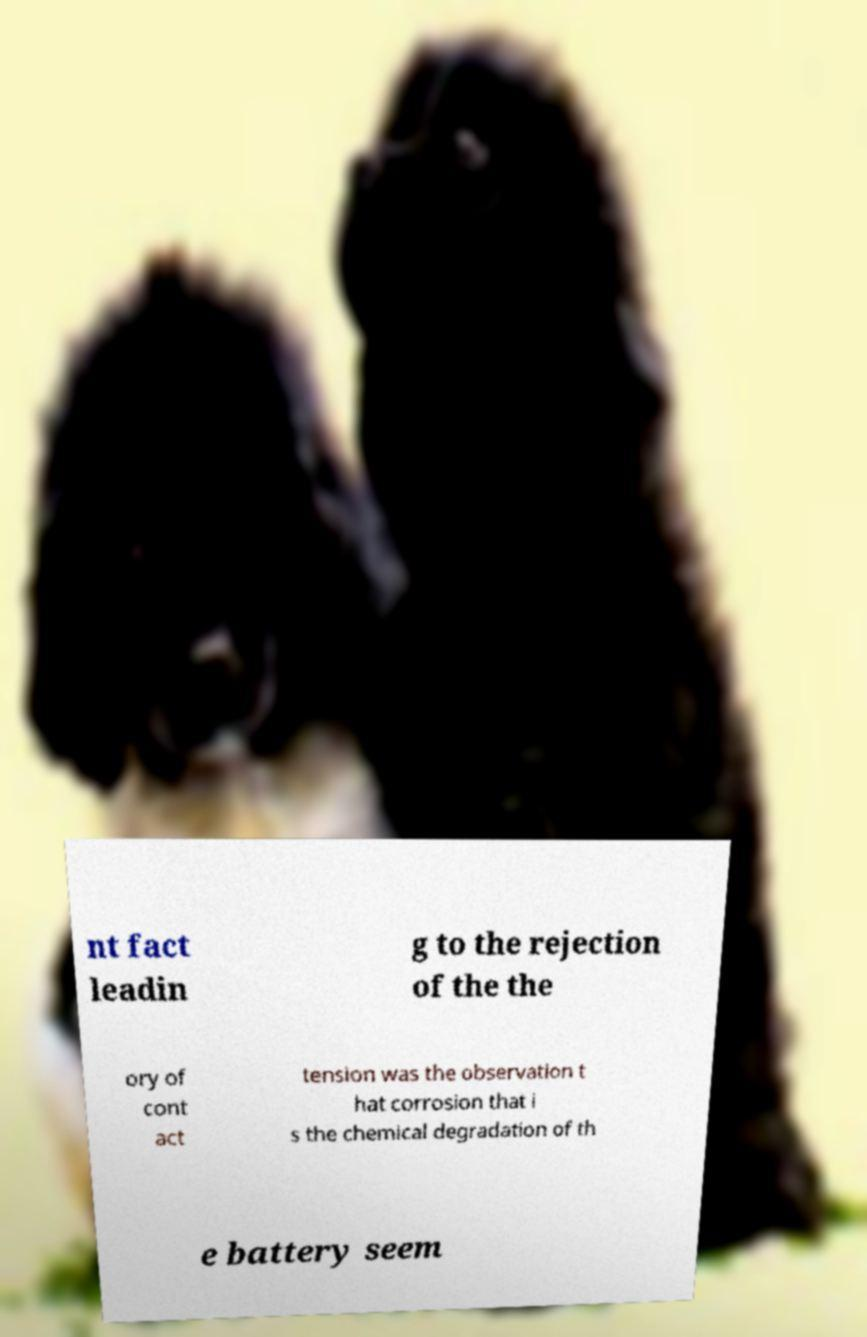Could you assist in decoding the text presented in this image and type it out clearly? nt fact leadin g to the rejection of the the ory of cont act tension was the observation t hat corrosion that i s the chemical degradation of th e battery seem 